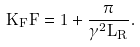Convert formula to latex. <formula><loc_0><loc_0><loc_500><loc_500>K _ { F } F = 1 + \frac { \pi } { \gamma ^ { 2 } L _ { R } } .</formula> 